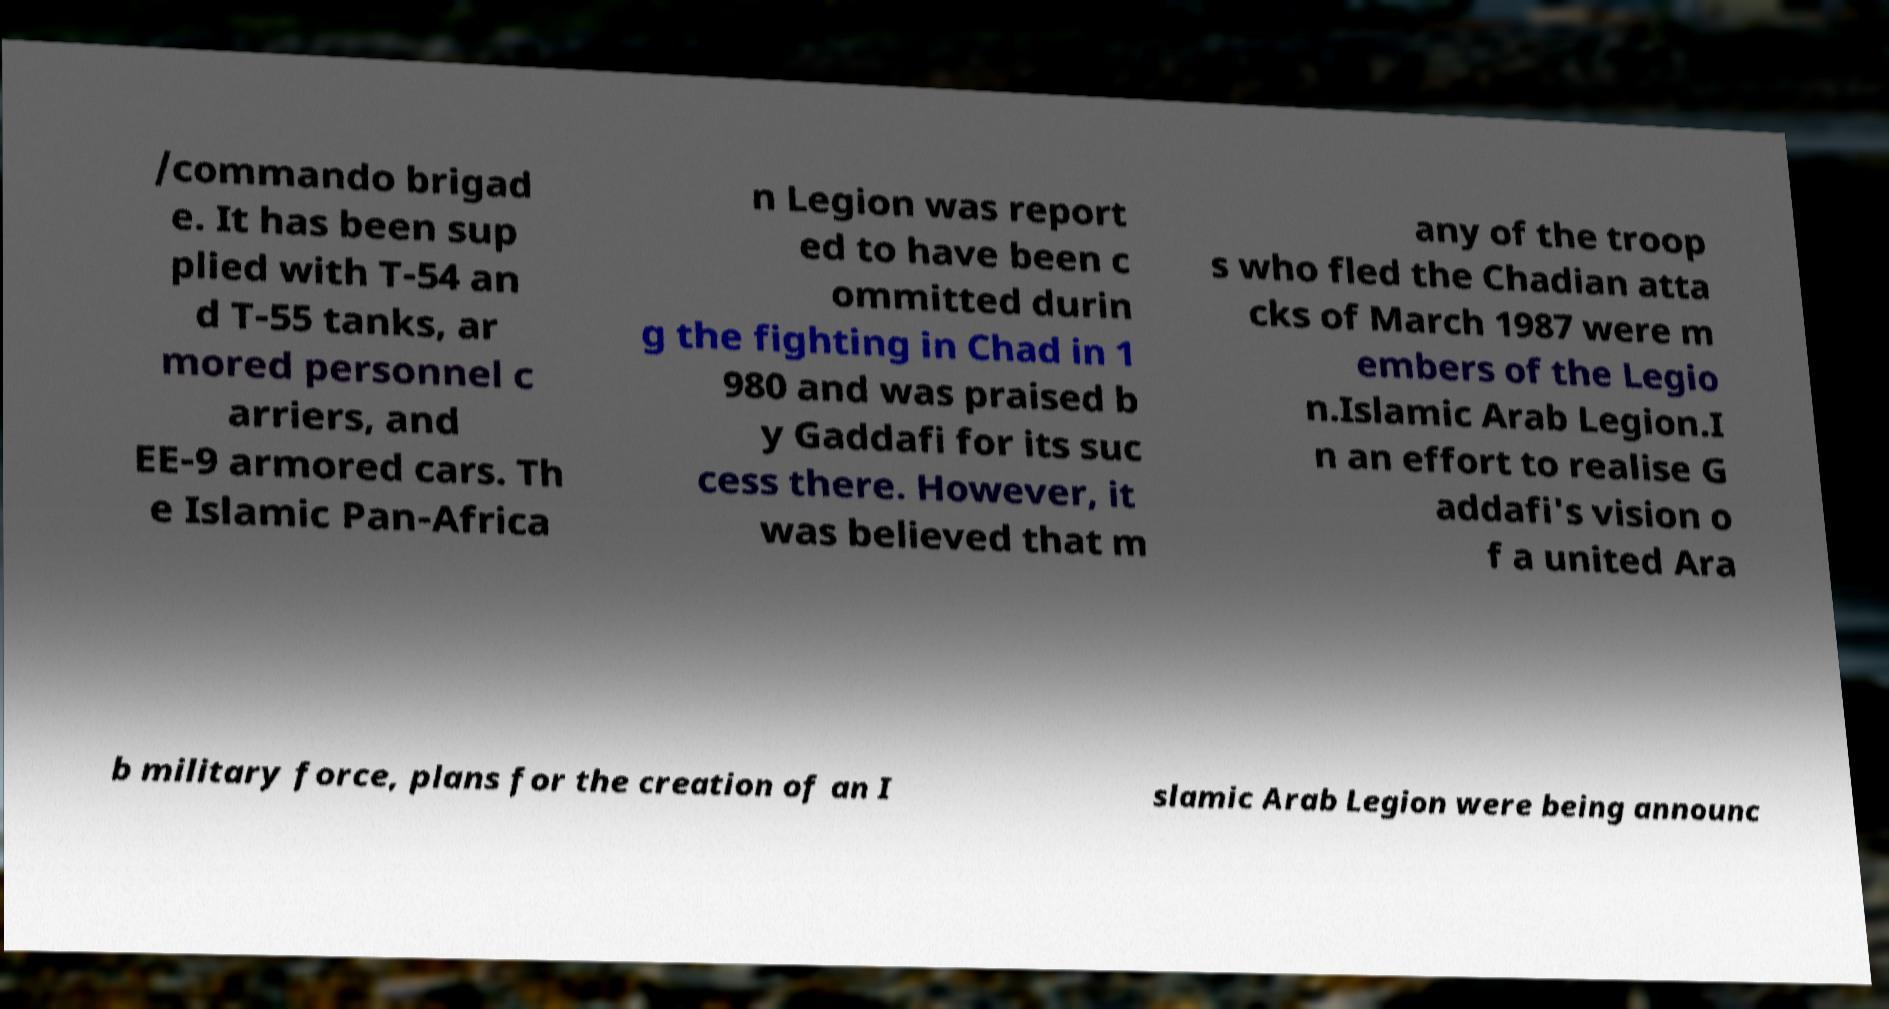Could you assist in decoding the text presented in this image and type it out clearly? /commando brigad e. It has been sup plied with T-54 an d T-55 tanks, ar mored personnel c arriers, and EE-9 armored cars. Th e Islamic Pan-Africa n Legion was report ed to have been c ommitted durin g the fighting in Chad in 1 980 and was praised b y Gaddafi for its suc cess there. However, it was believed that m any of the troop s who fled the Chadian atta cks of March 1987 were m embers of the Legio n.Islamic Arab Legion.I n an effort to realise G addafi's vision o f a united Ara b military force, plans for the creation of an I slamic Arab Legion were being announc 